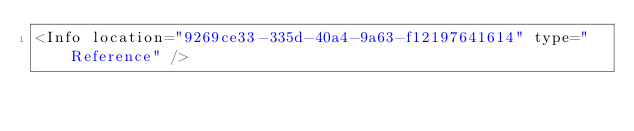Convert code to text. <code><loc_0><loc_0><loc_500><loc_500><_XML_><Info location="9269ce33-335d-40a4-9a63-f12197641614" type="Reference" /></code> 